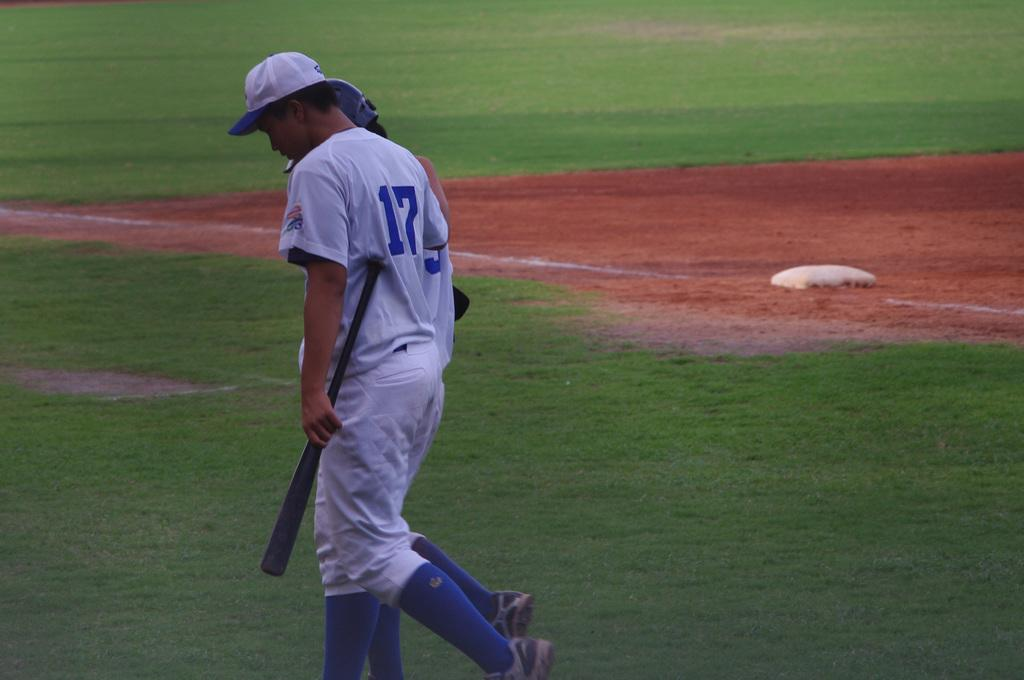<image>
Share a concise interpretation of the image provided. A man with a 17 on the back of his jersey is on the baseball field. 